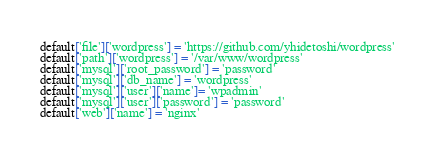<code> <loc_0><loc_0><loc_500><loc_500><_Ruby_>default['file']['wordpress'] = 'https://github.com/yhidetoshi/wordpress'
default['path']['wordpress'] = '/var/www/wordpress'
default['mysql']['root_password'] = 'password'
default['mysql']['db_name'] = 'wordpress'
default['mysql']['user']['name']= 'wpadmin'
default['mysql']['user']['password'] = 'password'
default['web']['name'] = 'nginx'
</code> 